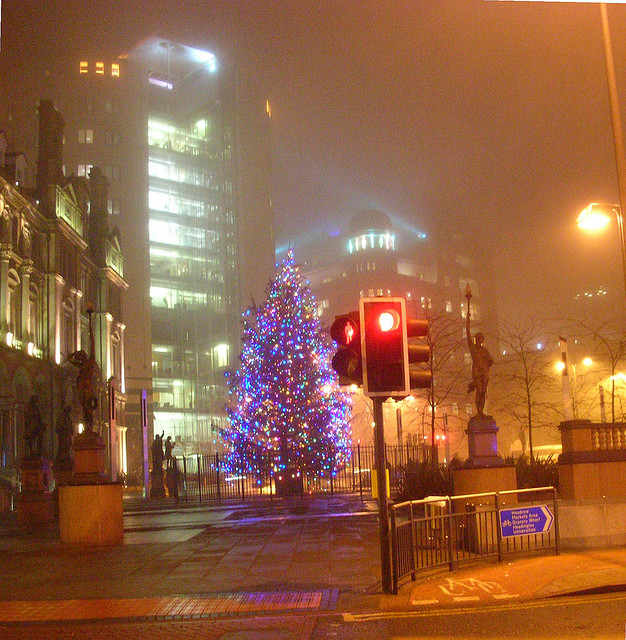<image>What is the speed limit? I don't know what the speed limit is. It can be any number from '0' to '35'. What is the speed limit? It is unclear what the speed limit is. It can be both 25 mph or 30 mph. 